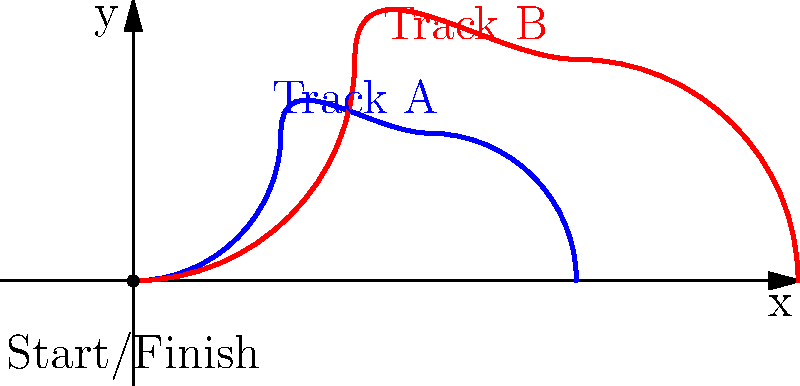Two horse racing tracks are plotted on a Cartesian plane as shown above. Track A (blue) and Track B (red) both start and end at the origin (0,0). If a horse maintains a constant speed throughout each track, which track would result in a faster race time? Assume the horse's speed is the same for both tracks. To determine which track would result in a faster race time, we need to compare the lengths of the two paths. Since the horse's speed is constant and the same for both tracks, the shorter path will result in a faster race time.

Step 1: Analyze the shapes of the tracks.
Both tracks are smooth curves that start and end at the origin, but they have different shapes and reach different maximum heights.

Step 2: Compare the maximum heights.
Track A reaches a maximum height of 2 units on the y-axis.
Track B reaches a maximum height of 3 units on the y-axis.

Step 3: Compare the horizontal distances.
Track A extends to 6 units on the x-axis.
Track B extends to 9 units on the x-axis.

Step 4: Consider the path lengths.
Although we can't calculate the exact lengths without more precise mathematical functions, we can make a reasonable comparison based on the visual information:
- Track A is shorter in both vertical and horizontal extent.
- Track A has a more compact curve compared to Track B.
- Track B covers more area, indicating a longer path.

Step 5: Conclude based on the analysis.
Since Track A is shorter in both dimensions and appears to have a more direct path, it would likely result in a faster race time for a horse moving at a constant speed.
Answer: Track A (blue) 